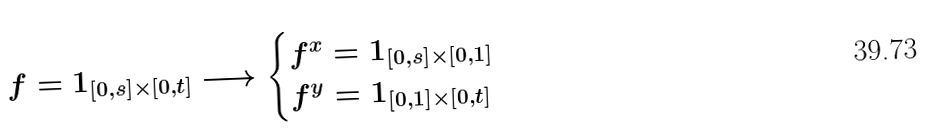<formula> <loc_0><loc_0><loc_500><loc_500>f = 1 _ { [ 0 , s ] \times [ 0 , t ] } \longrightarrow \begin{cases} f ^ { x } = 1 _ { [ 0 , s ] \times [ 0 , 1 ] } \\ f ^ { y } = 1 _ { [ 0 , 1 ] \times [ 0 , t ] } \end{cases}</formula> 